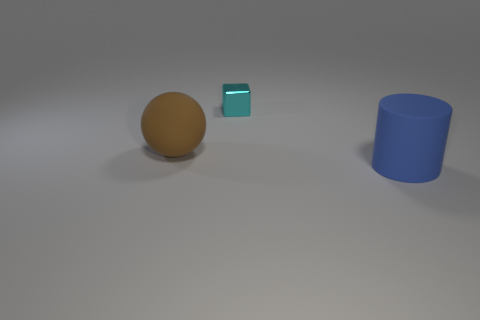Is there anything else that is the same size as the metallic cube?
Ensure brevity in your answer.  No. Is the tiny cyan metal object the same shape as the big blue matte object?
Give a very brief answer. No. There is a rubber thing that is in front of the large brown object; what number of blue matte cylinders are on the right side of it?
Offer a very short reply. 0. There is a large rubber thing that is right of the cyan shiny cube; does it have the same color as the tiny metallic object?
Provide a short and direct response. No. Do the cyan thing and the big thing that is behind the big blue matte thing have the same material?
Offer a terse response. No. What shape is the big thing behind the large blue object?
Ensure brevity in your answer.  Sphere. What number of other things are there of the same material as the small cyan cube
Give a very brief answer. 0. What is the size of the brown matte object?
Offer a terse response. Large. How many other objects are the same color as the small object?
Your response must be concise. 0. There is a object that is both in front of the tiny object and right of the rubber sphere; what is its color?
Offer a very short reply. Blue. 